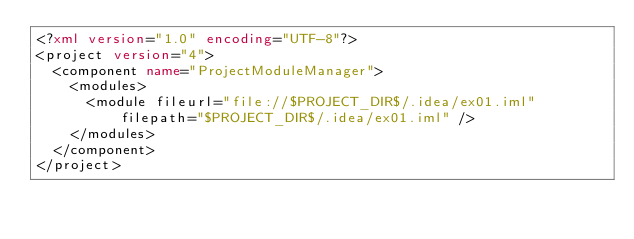<code> <loc_0><loc_0><loc_500><loc_500><_XML_><?xml version="1.0" encoding="UTF-8"?>
<project version="4">
  <component name="ProjectModuleManager">
    <modules>
      <module fileurl="file://$PROJECT_DIR$/.idea/ex01.iml" filepath="$PROJECT_DIR$/.idea/ex01.iml" />
    </modules>
  </component>
</project></code> 